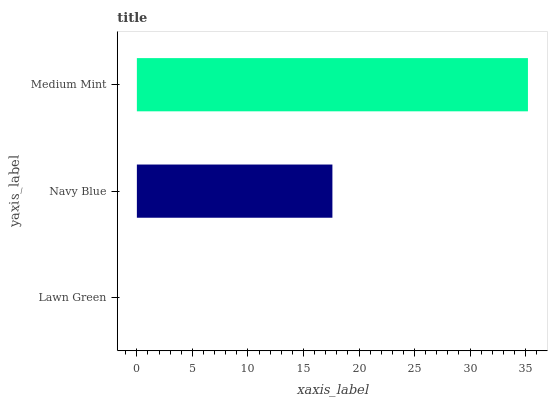Is Lawn Green the minimum?
Answer yes or no. Yes. Is Medium Mint the maximum?
Answer yes or no. Yes. Is Navy Blue the minimum?
Answer yes or no. No. Is Navy Blue the maximum?
Answer yes or no. No. Is Navy Blue greater than Lawn Green?
Answer yes or no. Yes. Is Lawn Green less than Navy Blue?
Answer yes or no. Yes. Is Lawn Green greater than Navy Blue?
Answer yes or no. No. Is Navy Blue less than Lawn Green?
Answer yes or no. No. Is Navy Blue the high median?
Answer yes or no. Yes. Is Navy Blue the low median?
Answer yes or no. Yes. Is Medium Mint the high median?
Answer yes or no. No. Is Lawn Green the low median?
Answer yes or no. No. 